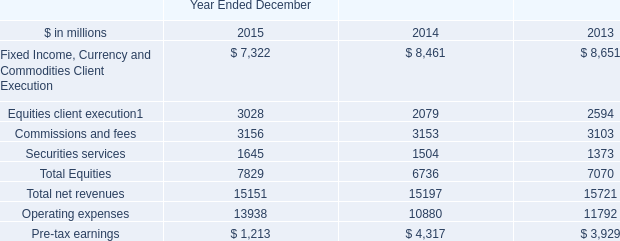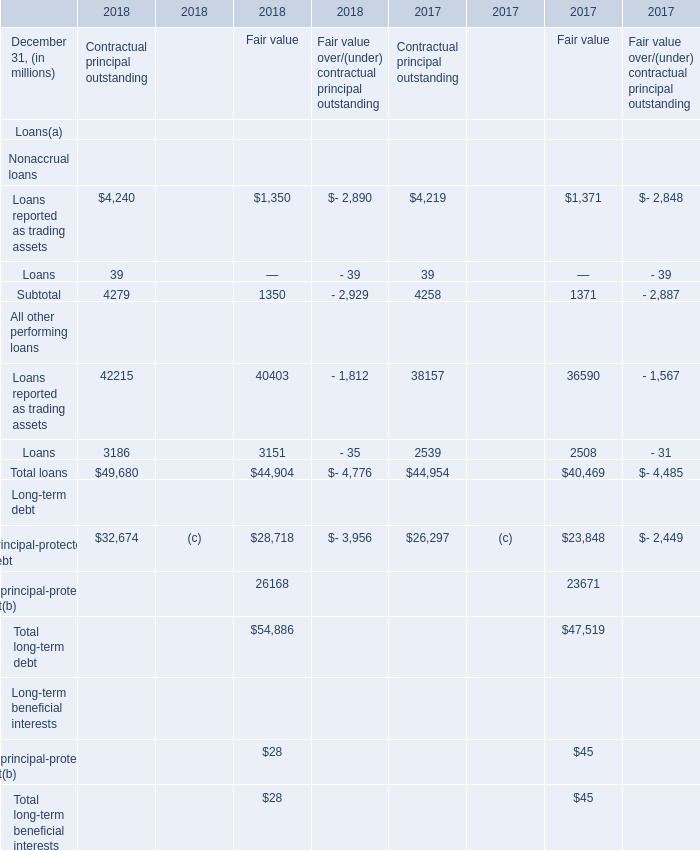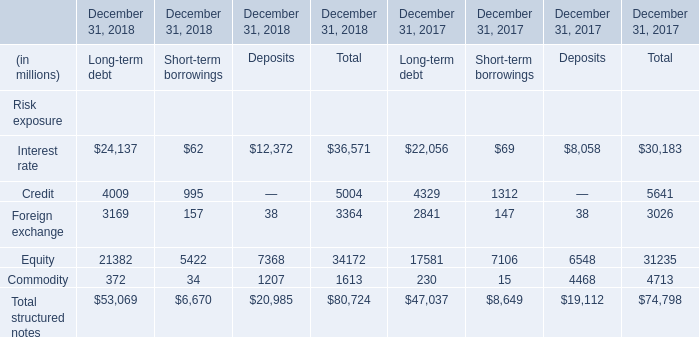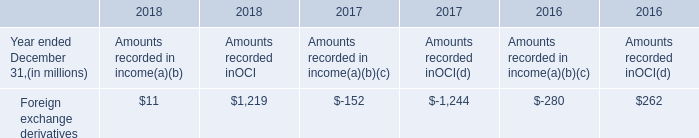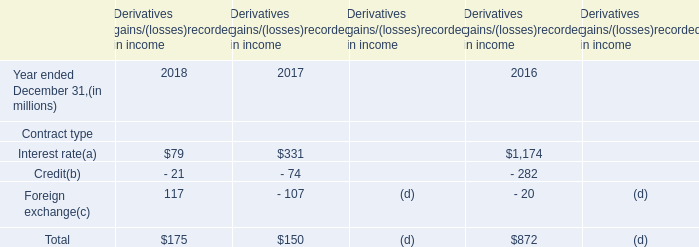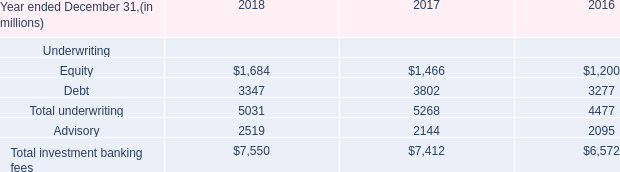If Equity for Total develops with the same increasing rate in 2018, what will it reach in 2019? (in million) 
Computations: (34172 * (1 + ((34172 - 31235) / 31235)))
Answer: 37385.16357. 